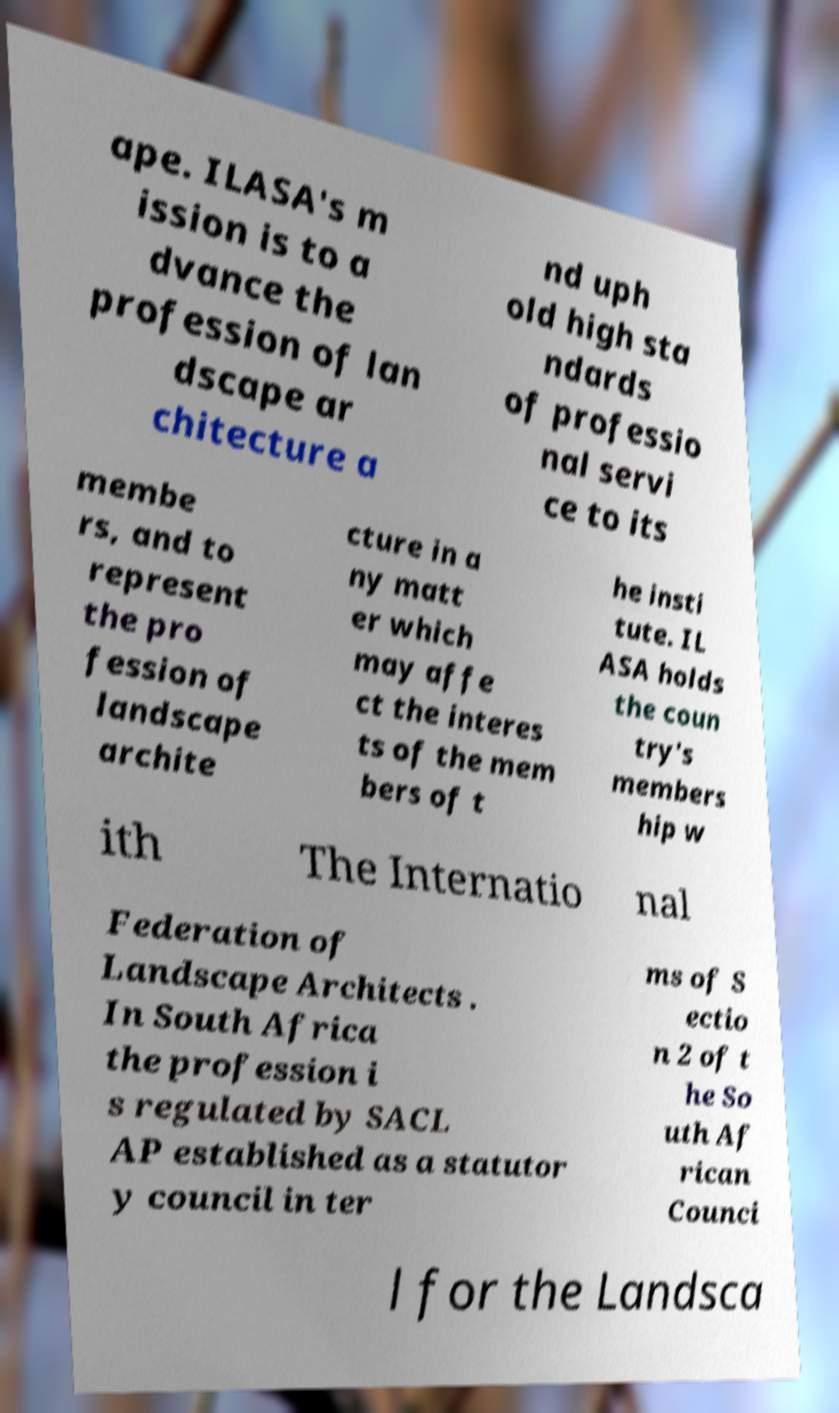What messages or text are displayed in this image? I need them in a readable, typed format. ape. ILASA's m ission is to a dvance the profession of lan dscape ar chitecture a nd uph old high sta ndards of professio nal servi ce to its membe rs, and to represent the pro fession of landscape archite cture in a ny matt er which may affe ct the interes ts of the mem bers of t he insti tute. IL ASA holds the coun try's members hip w ith The Internatio nal Federation of Landscape Architects . In South Africa the profession i s regulated by SACL AP established as a statutor y council in ter ms of S ectio n 2 of t he So uth Af rican Counci l for the Landsca 